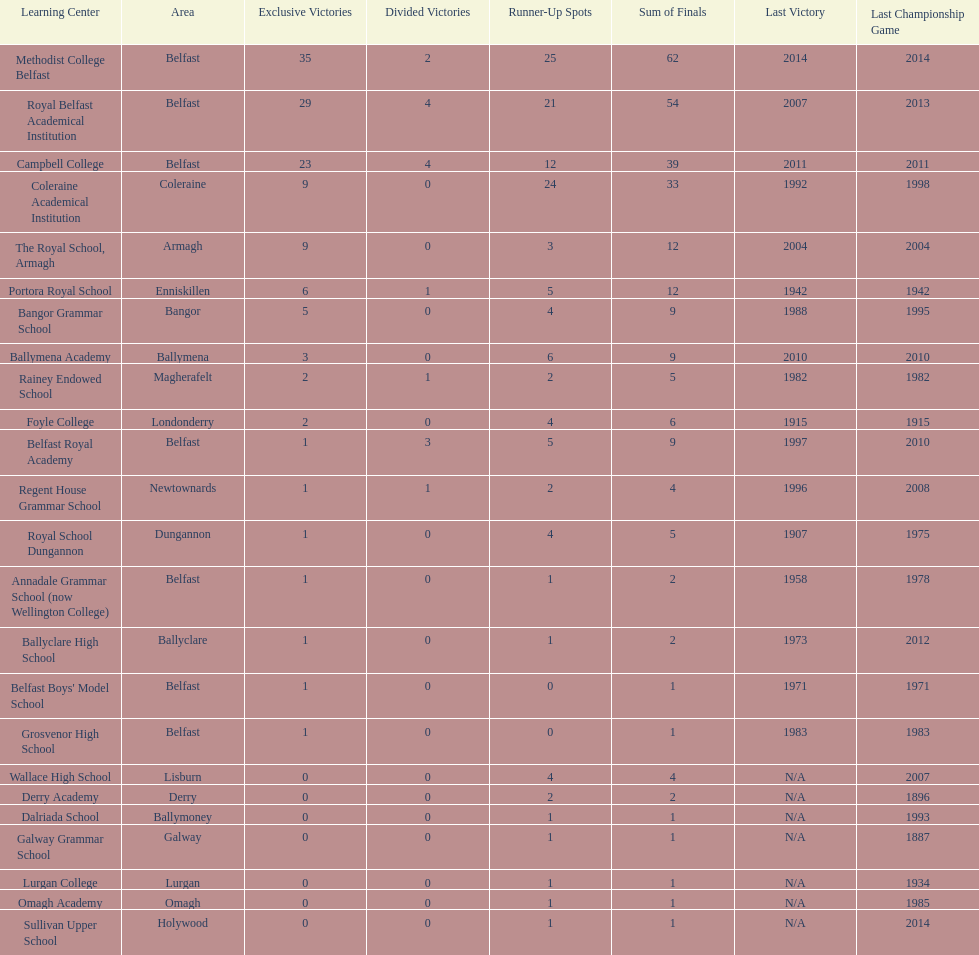Which two schools each had twelve total finals? The Royal School, Armagh, Portora Royal School. 